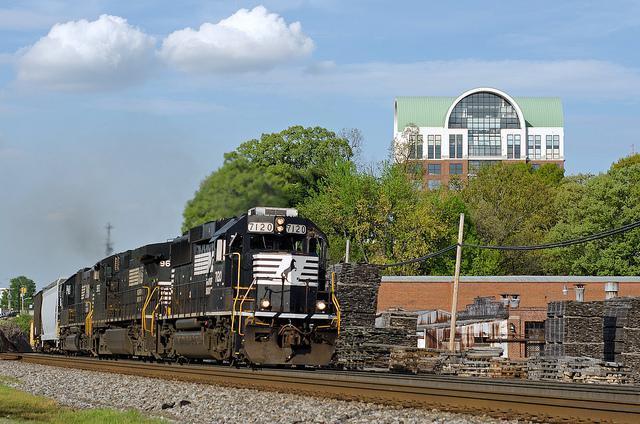How many puffy clouds are in the sky?
Give a very brief answer. 2. 